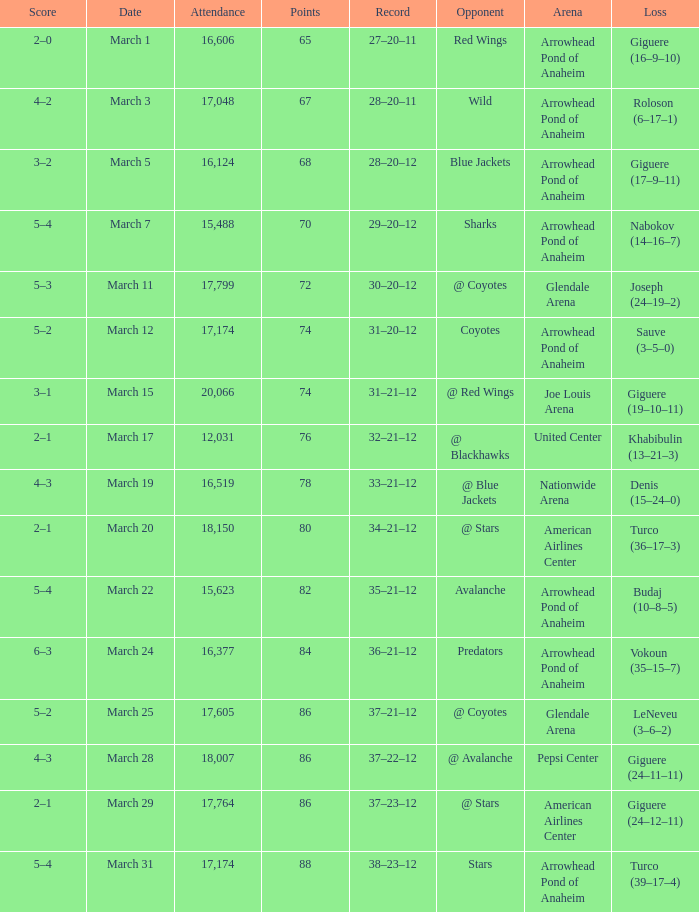What is the Record of the game with an Attendance of more than 16,124 and a Score of 6–3? 36–21–12. 